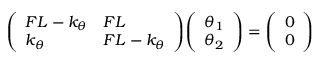Convert formula to latex. <formula><loc_0><loc_0><loc_500><loc_500>{ \left ( \begin{array} { l l } { F L - k _ { \theta } } & { F L } \\ { k _ { \theta } } & { F L - k _ { \theta } } \end{array} \right ) } { \left ( \begin{array} { l } { \theta _ { 1 } } \\ { \theta _ { 2 } } \end{array} \right ) } = { \left ( \begin{array} { l } { 0 } \\ { 0 } \end{array} \right ) }</formula> 